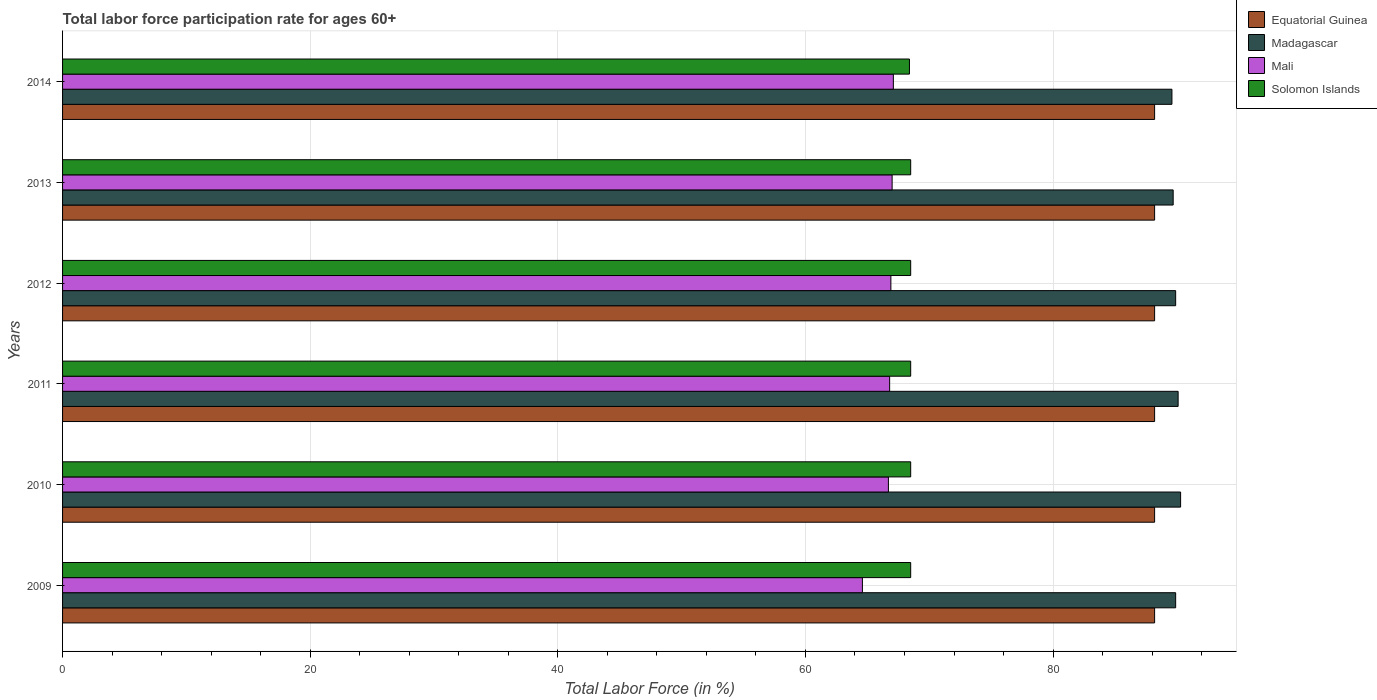How many different coloured bars are there?
Provide a succinct answer. 4. Are the number of bars on each tick of the Y-axis equal?
Offer a terse response. Yes. How many bars are there on the 1st tick from the top?
Offer a very short reply. 4. What is the labor force participation rate in Madagascar in 2014?
Give a very brief answer. 89.6. Across all years, what is the maximum labor force participation rate in Mali?
Keep it short and to the point. 67.1. Across all years, what is the minimum labor force participation rate in Solomon Islands?
Your answer should be very brief. 68.4. In which year was the labor force participation rate in Solomon Islands maximum?
Provide a short and direct response. 2009. What is the total labor force participation rate in Equatorial Guinea in the graph?
Make the answer very short. 529.2. What is the difference between the labor force participation rate in Mali in 2010 and that in 2012?
Your response must be concise. -0.2. What is the difference between the labor force participation rate in Equatorial Guinea in 2009 and the labor force participation rate in Mali in 2013?
Your response must be concise. 21.2. What is the average labor force participation rate in Madagascar per year?
Your response must be concise. 89.92. In the year 2011, what is the difference between the labor force participation rate in Solomon Islands and labor force participation rate in Madagascar?
Give a very brief answer. -21.6. Is the labor force participation rate in Solomon Islands in 2011 less than that in 2012?
Ensure brevity in your answer.  No. Is the difference between the labor force participation rate in Solomon Islands in 2009 and 2010 greater than the difference between the labor force participation rate in Madagascar in 2009 and 2010?
Give a very brief answer. Yes. What is the difference between the highest and the second highest labor force participation rate in Madagascar?
Your answer should be compact. 0.2. What is the difference between the highest and the lowest labor force participation rate in Equatorial Guinea?
Provide a succinct answer. 0. In how many years, is the labor force participation rate in Mali greater than the average labor force participation rate in Mali taken over all years?
Your answer should be compact. 5. Is it the case that in every year, the sum of the labor force participation rate in Equatorial Guinea and labor force participation rate in Mali is greater than the sum of labor force participation rate in Madagascar and labor force participation rate in Solomon Islands?
Your response must be concise. No. What does the 1st bar from the top in 2012 represents?
Your answer should be very brief. Solomon Islands. What does the 4th bar from the bottom in 2010 represents?
Provide a succinct answer. Solomon Islands. Is it the case that in every year, the sum of the labor force participation rate in Madagascar and labor force participation rate in Mali is greater than the labor force participation rate in Solomon Islands?
Give a very brief answer. Yes. How many bars are there?
Provide a short and direct response. 24. Are all the bars in the graph horizontal?
Provide a short and direct response. Yes. How many years are there in the graph?
Keep it short and to the point. 6. What is the difference between two consecutive major ticks on the X-axis?
Provide a succinct answer. 20. Are the values on the major ticks of X-axis written in scientific E-notation?
Provide a short and direct response. No. Does the graph contain any zero values?
Offer a terse response. No. Does the graph contain grids?
Your answer should be compact. Yes. What is the title of the graph?
Keep it short and to the point. Total labor force participation rate for ages 60+. Does "Burundi" appear as one of the legend labels in the graph?
Make the answer very short. No. What is the label or title of the Y-axis?
Your answer should be very brief. Years. What is the Total Labor Force (in %) in Equatorial Guinea in 2009?
Your answer should be compact. 88.2. What is the Total Labor Force (in %) in Madagascar in 2009?
Give a very brief answer. 89.9. What is the Total Labor Force (in %) in Mali in 2009?
Provide a succinct answer. 64.6. What is the Total Labor Force (in %) of Solomon Islands in 2009?
Offer a very short reply. 68.5. What is the Total Labor Force (in %) of Equatorial Guinea in 2010?
Offer a terse response. 88.2. What is the Total Labor Force (in %) of Madagascar in 2010?
Provide a short and direct response. 90.3. What is the Total Labor Force (in %) of Mali in 2010?
Offer a terse response. 66.7. What is the Total Labor Force (in %) in Solomon Islands in 2010?
Your answer should be compact. 68.5. What is the Total Labor Force (in %) in Equatorial Guinea in 2011?
Ensure brevity in your answer.  88.2. What is the Total Labor Force (in %) in Madagascar in 2011?
Give a very brief answer. 90.1. What is the Total Labor Force (in %) of Mali in 2011?
Offer a very short reply. 66.8. What is the Total Labor Force (in %) of Solomon Islands in 2011?
Provide a succinct answer. 68.5. What is the Total Labor Force (in %) of Equatorial Guinea in 2012?
Keep it short and to the point. 88.2. What is the Total Labor Force (in %) in Madagascar in 2012?
Keep it short and to the point. 89.9. What is the Total Labor Force (in %) in Mali in 2012?
Give a very brief answer. 66.9. What is the Total Labor Force (in %) of Solomon Islands in 2012?
Your response must be concise. 68.5. What is the Total Labor Force (in %) in Equatorial Guinea in 2013?
Your answer should be very brief. 88.2. What is the Total Labor Force (in %) in Madagascar in 2013?
Your answer should be very brief. 89.7. What is the Total Labor Force (in %) of Solomon Islands in 2013?
Your response must be concise. 68.5. What is the Total Labor Force (in %) of Equatorial Guinea in 2014?
Provide a succinct answer. 88.2. What is the Total Labor Force (in %) of Madagascar in 2014?
Offer a terse response. 89.6. What is the Total Labor Force (in %) in Mali in 2014?
Provide a succinct answer. 67.1. What is the Total Labor Force (in %) of Solomon Islands in 2014?
Provide a short and direct response. 68.4. Across all years, what is the maximum Total Labor Force (in %) in Equatorial Guinea?
Provide a short and direct response. 88.2. Across all years, what is the maximum Total Labor Force (in %) in Madagascar?
Provide a short and direct response. 90.3. Across all years, what is the maximum Total Labor Force (in %) in Mali?
Your answer should be very brief. 67.1. Across all years, what is the maximum Total Labor Force (in %) in Solomon Islands?
Offer a very short reply. 68.5. Across all years, what is the minimum Total Labor Force (in %) in Equatorial Guinea?
Your answer should be very brief. 88.2. Across all years, what is the minimum Total Labor Force (in %) in Madagascar?
Your answer should be very brief. 89.6. Across all years, what is the minimum Total Labor Force (in %) of Mali?
Offer a terse response. 64.6. Across all years, what is the minimum Total Labor Force (in %) of Solomon Islands?
Your answer should be compact. 68.4. What is the total Total Labor Force (in %) in Equatorial Guinea in the graph?
Make the answer very short. 529.2. What is the total Total Labor Force (in %) of Madagascar in the graph?
Give a very brief answer. 539.5. What is the total Total Labor Force (in %) in Mali in the graph?
Your answer should be compact. 399.1. What is the total Total Labor Force (in %) in Solomon Islands in the graph?
Ensure brevity in your answer.  410.9. What is the difference between the Total Labor Force (in %) of Equatorial Guinea in 2009 and that in 2010?
Ensure brevity in your answer.  0. What is the difference between the Total Labor Force (in %) in Madagascar in 2009 and that in 2010?
Provide a short and direct response. -0.4. What is the difference between the Total Labor Force (in %) of Mali in 2009 and that in 2010?
Your answer should be very brief. -2.1. What is the difference between the Total Labor Force (in %) in Mali in 2009 and that in 2011?
Offer a very short reply. -2.2. What is the difference between the Total Labor Force (in %) in Solomon Islands in 2009 and that in 2011?
Your answer should be compact. 0. What is the difference between the Total Labor Force (in %) in Madagascar in 2009 and that in 2012?
Offer a very short reply. 0. What is the difference between the Total Labor Force (in %) of Mali in 2009 and that in 2012?
Offer a terse response. -2.3. What is the difference between the Total Labor Force (in %) of Solomon Islands in 2009 and that in 2012?
Offer a very short reply. 0. What is the difference between the Total Labor Force (in %) of Madagascar in 2009 and that in 2013?
Provide a short and direct response. 0.2. What is the difference between the Total Labor Force (in %) of Mali in 2009 and that in 2013?
Give a very brief answer. -2.4. What is the difference between the Total Labor Force (in %) in Solomon Islands in 2009 and that in 2013?
Offer a very short reply. 0. What is the difference between the Total Labor Force (in %) of Equatorial Guinea in 2009 and that in 2014?
Your answer should be very brief. 0. What is the difference between the Total Labor Force (in %) of Mali in 2009 and that in 2014?
Your answer should be very brief. -2.5. What is the difference between the Total Labor Force (in %) in Equatorial Guinea in 2010 and that in 2011?
Your response must be concise. 0. What is the difference between the Total Labor Force (in %) of Mali in 2010 and that in 2011?
Keep it short and to the point. -0.1. What is the difference between the Total Labor Force (in %) in Solomon Islands in 2010 and that in 2012?
Offer a terse response. 0. What is the difference between the Total Labor Force (in %) of Mali in 2010 and that in 2013?
Provide a succinct answer. -0.3. What is the difference between the Total Labor Force (in %) in Solomon Islands in 2010 and that in 2013?
Offer a very short reply. 0. What is the difference between the Total Labor Force (in %) in Equatorial Guinea in 2010 and that in 2014?
Offer a terse response. 0. What is the difference between the Total Labor Force (in %) of Mali in 2010 and that in 2014?
Your response must be concise. -0.4. What is the difference between the Total Labor Force (in %) of Mali in 2011 and that in 2012?
Provide a succinct answer. -0.1. What is the difference between the Total Labor Force (in %) of Solomon Islands in 2011 and that in 2012?
Your answer should be compact. 0. What is the difference between the Total Labor Force (in %) in Solomon Islands in 2011 and that in 2013?
Ensure brevity in your answer.  0. What is the difference between the Total Labor Force (in %) in Mali in 2011 and that in 2014?
Ensure brevity in your answer.  -0.3. What is the difference between the Total Labor Force (in %) of Equatorial Guinea in 2012 and that in 2013?
Offer a very short reply. 0. What is the difference between the Total Labor Force (in %) of Mali in 2012 and that in 2013?
Offer a terse response. -0.1. What is the difference between the Total Labor Force (in %) of Solomon Islands in 2012 and that in 2013?
Offer a terse response. 0. What is the difference between the Total Labor Force (in %) in Equatorial Guinea in 2012 and that in 2014?
Your answer should be very brief. 0. What is the difference between the Total Labor Force (in %) in Madagascar in 2012 and that in 2014?
Offer a very short reply. 0.3. What is the difference between the Total Labor Force (in %) of Madagascar in 2013 and that in 2014?
Offer a terse response. 0.1. What is the difference between the Total Labor Force (in %) in Equatorial Guinea in 2009 and the Total Labor Force (in %) in Mali in 2010?
Give a very brief answer. 21.5. What is the difference between the Total Labor Force (in %) of Madagascar in 2009 and the Total Labor Force (in %) of Mali in 2010?
Offer a very short reply. 23.2. What is the difference between the Total Labor Force (in %) in Madagascar in 2009 and the Total Labor Force (in %) in Solomon Islands in 2010?
Provide a short and direct response. 21.4. What is the difference between the Total Labor Force (in %) of Mali in 2009 and the Total Labor Force (in %) of Solomon Islands in 2010?
Provide a short and direct response. -3.9. What is the difference between the Total Labor Force (in %) of Equatorial Guinea in 2009 and the Total Labor Force (in %) of Madagascar in 2011?
Your response must be concise. -1.9. What is the difference between the Total Labor Force (in %) of Equatorial Guinea in 2009 and the Total Labor Force (in %) of Mali in 2011?
Give a very brief answer. 21.4. What is the difference between the Total Labor Force (in %) of Equatorial Guinea in 2009 and the Total Labor Force (in %) of Solomon Islands in 2011?
Ensure brevity in your answer.  19.7. What is the difference between the Total Labor Force (in %) in Madagascar in 2009 and the Total Labor Force (in %) in Mali in 2011?
Your answer should be compact. 23.1. What is the difference between the Total Labor Force (in %) in Madagascar in 2009 and the Total Labor Force (in %) in Solomon Islands in 2011?
Offer a terse response. 21.4. What is the difference between the Total Labor Force (in %) in Equatorial Guinea in 2009 and the Total Labor Force (in %) in Mali in 2012?
Your answer should be very brief. 21.3. What is the difference between the Total Labor Force (in %) of Equatorial Guinea in 2009 and the Total Labor Force (in %) of Solomon Islands in 2012?
Your answer should be compact. 19.7. What is the difference between the Total Labor Force (in %) in Madagascar in 2009 and the Total Labor Force (in %) in Solomon Islands in 2012?
Ensure brevity in your answer.  21.4. What is the difference between the Total Labor Force (in %) of Mali in 2009 and the Total Labor Force (in %) of Solomon Islands in 2012?
Keep it short and to the point. -3.9. What is the difference between the Total Labor Force (in %) in Equatorial Guinea in 2009 and the Total Labor Force (in %) in Mali in 2013?
Provide a succinct answer. 21.2. What is the difference between the Total Labor Force (in %) in Equatorial Guinea in 2009 and the Total Labor Force (in %) in Solomon Islands in 2013?
Ensure brevity in your answer.  19.7. What is the difference between the Total Labor Force (in %) of Madagascar in 2009 and the Total Labor Force (in %) of Mali in 2013?
Your answer should be very brief. 22.9. What is the difference between the Total Labor Force (in %) in Madagascar in 2009 and the Total Labor Force (in %) in Solomon Islands in 2013?
Provide a succinct answer. 21.4. What is the difference between the Total Labor Force (in %) of Mali in 2009 and the Total Labor Force (in %) of Solomon Islands in 2013?
Your answer should be very brief. -3.9. What is the difference between the Total Labor Force (in %) of Equatorial Guinea in 2009 and the Total Labor Force (in %) of Mali in 2014?
Offer a very short reply. 21.1. What is the difference between the Total Labor Force (in %) in Equatorial Guinea in 2009 and the Total Labor Force (in %) in Solomon Islands in 2014?
Your answer should be very brief. 19.8. What is the difference between the Total Labor Force (in %) of Madagascar in 2009 and the Total Labor Force (in %) of Mali in 2014?
Give a very brief answer. 22.8. What is the difference between the Total Labor Force (in %) in Madagascar in 2009 and the Total Labor Force (in %) in Solomon Islands in 2014?
Your response must be concise. 21.5. What is the difference between the Total Labor Force (in %) in Equatorial Guinea in 2010 and the Total Labor Force (in %) in Madagascar in 2011?
Provide a short and direct response. -1.9. What is the difference between the Total Labor Force (in %) in Equatorial Guinea in 2010 and the Total Labor Force (in %) in Mali in 2011?
Keep it short and to the point. 21.4. What is the difference between the Total Labor Force (in %) in Madagascar in 2010 and the Total Labor Force (in %) in Solomon Islands in 2011?
Ensure brevity in your answer.  21.8. What is the difference between the Total Labor Force (in %) of Equatorial Guinea in 2010 and the Total Labor Force (in %) of Mali in 2012?
Give a very brief answer. 21.3. What is the difference between the Total Labor Force (in %) in Equatorial Guinea in 2010 and the Total Labor Force (in %) in Solomon Islands in 2012?
Your answer should be compact. 19.7. What is the difference between the Total Labor Force (in %) of Madagascar in 2010 and the Total Labor Force (in %) of Mali in 2012?
Give a very brief answer. 23.4. What is the difference between the Total Labor Force (in %) of Madagascar in 2010 and the Total Labor Force (in %) of Solomon Islands in 2012?
Provide a succinct answer. 21.8. What is the difference between the Total Labor Force (in %) in Mali in 2010 and the Total Labor Force (in %) in Solomon Islands in 2012?
Offer a terse response. -1.8. What is the difference between the Total Labor Force (in %) in Equatorial Guinea in 2010 and the Total Labor Force (in %) in Madagascar in 2013?
Your answer should be very brief. -1.5. What is the difference between the Total Labor Force (in %) of Equatorial Guinea in 2010 and the Total Labor Force (in %) of Mali in 2013?
Keep it short and to the point. 21.2. What is the difference between the Total Labor Force (in %) in Equatorial Guinea in 2010 and the Total Labor Force (in %) in Solomon Islands in 2013?
Your answer should be compact. 19.7. What is the difference between the Total Labor Force (in %) of Madagascar in 2010 and the Total Labor Force (in %) of Mali in 2013?
Offer a very short reply. 23.3. What is the difference between the Total Labor Force (in %) in Madagascar in 2010 and the Total Labor Force (in %) in Solomon Islands in 2013?
Your answer should be very brief. 21.8. What is the difference between the Total Labor Force (in %) of Equatorial Guinea in 2010 and the Total Labor Force (in %) of Madagascar in 2014?
Give a very brief answer. -1.4. What is the difference between the Total Labor Force (in %) in Equatorial Guinea in 2010 and the Total Labor Force (in %) in Mali in 2014?
Offer a terse response. 21.1. What is the difference between the Total Labor Force (in %) in Equatorial Guinea in 2010 and the Total Labor Force (in %) in Solomon Islands in 2014?
Offer a very short reply. 19.8. What is the difference between the Total Labor Force (in %) of Madagascar in 2010 and the Total Labor Force (in %) of Mali in 2014?
Offer a terse response. 23.2. What is the difference between the Total Labor Force (in %) in Madagascar in 2010 and the Total Labor Force (in %) in Solomon Islands in 2014?
Keep it short and to the point. 21.9. What is the difference between the Total Labor Force (in %) in Equatorial Guinea in 2011 and the Total Labor Force (in %) in Mali in 2012?
Ensure brevity in your answer.  21.3. What is the difference between the Total Labor Force (in %) of Equatorial Guinea in 2011 and the Total Labor Force (in %) of Solomon Islands in 2012?
Your response must be concise. 19.7. What is the difference between the Total Labor Force (in %) of Madagascar in 2011 and the Total Labor Force (in %) of Mali in 2012?
Your answer should be very brief. 23.2. What is the difference between the Total Labor Force (in %) in Madagascar in 2011 and the Total Labor Force (in %) in Solomon Islands in 2012?
Your answer should be very brief. 21.6. What is the difference between the Total Labor Force (in %) in Mali in 2011 and the Total Labor Force (in %) in Solomon Islands in 2012?
Provide a short and direct response. -1.7. What is the difference between the Total Labor Force (in %) in Equatorial Guinea in 2011 and the Total Labor Force (in %) in Mali in 2013?
Give a very brief answer. 21.2. What is the difference between the Total Labor Force (in %) in Equatorial Guinea in 2011 and the Total Labor Force (in %) in Solomon Islands in 2013?
Keep it short and to the point. 19.7. What is the difference between the Total Labor Force (in %) of Madagascar in 2011 and the Total Labor Force (in %) of Mali in 2013?
Offer a terse response. 23.1. What is the difference between the Total Labor Force (in %) in Madagascar in 2011 and the Total Labor Force (in %) in Solomon Islands in 2013?
Offer a very short reply. 21.6. What is the difference between the Total Labor Force (in %) in Mali in 2011 and the Total Labor Force (in %) in Solomon Islands in 2013?
Your answer should be compact. -1.7. What is the difference between the Total Labor Force (in %) in Equatorial Guinea in 2011 and the Total Labor Force (in %) in Mali in 2014?
Provide a short and direct response. 21.1. What is the difference between the Total Labor Force (in %) of Equatorial Guinea in 2011 and the Total Labor Force (in %) of Solomon Islands in 2014?
Your response must be concise. 19.8. What is the difference between the Total Labor Force (in %) of Madagascar in 2011 and the Total Labor Force (in %) of Solomon Islands in 2014?
Your answer should be very brief. 21.7. What is the difference between the Total Labor Force (in %) in Equatorial Guinea in 2012 and the Total Labor Force (in %) in Mali in 2013?
Offer a terse response. 21.2. What is the difference between the Total Labor Force (in %) of Equatorial Guinea in 2012 and the Total Labor Force (in %) of Solomon Islands in 2013?
Give a very brief answer. 19.7. What is the difference between the Total Labor Force (in %) of Madagascar in 2012 and the Total Labor Force (in %) of Mali in 2013?
Offer a very short reply. 22.9. What is the difference between the Total Labor Force (in %) in Madagascar in 2012 and the Total Labor Force (in %) in Solomon Islands in 2013?
Your answer should be very brief. 21.4. What is the difference between the Total Labor Force (in %) of Mali in 2012 and the Total Labor Force (in %) of Solomon Islands in 2013?
Offer a terse response. -1.6. What is the difference between the Total Labor Force (in %) in Equatorial Guinea in 2012 and the Total Labor Force (in %) in Mali in 2014?
Keep it short and to the point. 21.1. What is the difference between the Total Labor Force (in %) of Equatorial Guinea in 2012 and the Total Labor Force (in %) of Solomon Islands in 2014?
Provide a succinct answer. 19.8. What is the difference between the Total Labor Force (in %) in Madagascar in 2012 and the Total Labor Force (in %) in Mali in 2014?
Your answer should be very brief. 22.8. What is the difference between the Total Labor Force (in %) in Madagascar in 2012 and the Total Labor Force (in %) in Solomon Islands in 2014?
Your answer should be compact. 21.5. What is the difference between the Total Labor Force (in %) of Mali in 2012 and the Total Labor Force (in %) of Solomon Islands in 2014?
Your answer should be very brief. -1.5. What is the difference between the Total Labor Force (in %) in Equatorial Guinea in 2013 and the Total Labor Force (in %) in Mali in 2014?
Provide a short and direct response. 21.1. What is the difference between the Total Labor Force (in %) of Equatorial Guinea in 2013 and the Total Labor Force (in %) of Solomon Islands in 2014?
Provide a short and direct response. 19.8. What is the difference between the Total Labor Force (in %) of Madagascar in 2013 and the Total Labor Force (in %) of Mali in 2014?
Provide a short and direct response. 22.6. What is the difference between the Total Labor Force (in %) of Madagascar in 2013 and the Total Labor Force (in %) of Solomon Islands in 2014?
Your answer should be very brief. 21.3. What is the difference between the Total Labor Force (in %) in Mali in 2013 and the Total Labor Force (in %) in Solomon Islands in 2014?
Ensure brevity in your answer.  -1.4. What is the average Total Labor Force (in %) of Equatorial Guinea per year?
Your answer should be very brief. 88.2. What is the average Total Labor Force (in %) of Madagascar per year?
Your answer should be compact. 89.92. What is the average Total Labor Force (in %) in Mali per year?
Provide a short and direct response. 66.52. What is the average Total Labor Force (in %) in Solomon Islands per year?
Your answer should be very brief. 68.48. In the year 2009, what is the difference between the Total Labor Force (in %) in Equatorial Guinea and Total Labor Force (in %) in Madagascar?
Make the answer very short. -1.7. In the year 2009, what is the difference between the Total Labor Force (in %) in Equatorial Guinea and Total Labor Force (in %) in Mali?
Keep it short and to the point. 23.6. In the year 2009, what is the difference between the Total Labor Force (in %) in Madagascar and Total Labor Force (in %) in Mali?
Offer a terse response. 25.3. In the year 2009, what is the difference between the Total Labor Force (in %) in Madagascar and Total Labor Force (in %) in Solomon Islands?
Make the answer very short. 21.4. In the year 2010, what is the difference between the Total Labor Force (in %) in Equatorial Guinea and Total Labor Force (in %) in Mali?
Offer a terse response. 21.5. In the year 2010, what is the difference between the Total Labor Force (in %) of Equatorial Guinea and Total Labor Force (in %) of Solomon Islands?
Provide a succinct answer. 19.7. In the year 2010, what is the difference between the Total Labor Force (in %) of Madagascar and Total Labor Force (in %) of Mali?
Offer a very short reply. 23.6. In the year 2010, what is the difference between the Total Labor Force (in %) of Madagascar and Total Labor Force (in %) of Solomon Islands?
Give a very brief answer. 21.8. In the year 2010, what is the difference between the Total Labor Force (in %) in Mali and Total Labor Force (in %) in Solomon Islands?
Ensure brevity in your answer.  -1.8. In the year 2011, what is the difference between the Total Labor Force (in %) of Equatorial Guinea and Total Labor Force (in %) of Madagascar?
Offer a very short reply. -1.9. In the year 2011, what is the difference between the Total Labor Force (in %) of Equatorial Guinea and Total Labor Force (in %) of Mali?
Give a very brief answer. 21.4. In the year 2011, what is the difference between the Total Labor Force (in %) in Equatorial Guinea and Total Labor Force (in %) in Solomon Islands?
Provide a succinct answer. 19.7. In the year 2011, what is the difference between the Total Labor Force (in %) of Madagascar and Total Labor Force (in %) of Mali?
Your answer should be very brief. 23.3. In the year 2011, what is the difference between the Total Labor Force (in %) of Madagascar and Total Labor Force (in %) of Solomon Islands?
Give a very brief answer. 21.6. In the year 2011, what is the difference between the Total Labor Force (in %) of Mali and Total Labor Force (in %) of Solomon Islands?
Your response must be concise. -1.7. In the year 2012, what is the difference between the Total Labor Force (in %) in Equatorial Guinea and Total Labor Force (in %) in Mali?
Ensure brevity in your answer.  21.3. In the year 2012, what is the difference between the Total Labor Force (in %) in Equatorial Guinea and Total Labor Force (in %) in Solomon Islands?
Ensure brevity in your answer.  19.7. In the year 2012, what is the difference between the Total Labor Force (in %) of Madagascar and Total Labor Force (in %) of Mali?
Your answer should be compact. 23. In the year 2012, what is the difference between the Total Labor Force (in %) in Madagascar and Total Labor Force (in %) in Solomon Islands?
Your answer should be very brief. 21.4. In the year 2013, what is the difference between the Total Labor Force (in %) of Equatorial Guinea and Total Labor Force (in %) of Madagascar?
Your answer should be compact. -1.5. In the year 2013, what is the difference between the Total Labor Force (in %) of Equatorial Guinea and Total Labor Force (in %) of Mali?
Ensure brevity in your answer.  21.2. In the year 2013, what is the difference between the Total Labor Force (in %) of Madagascar and Total Labor Force (in %) of Mali?
Your answer should be very brief. 22.7. In the year 2013, what is the difference between the Total Labor Force (in %) in Madagascar and Total Labor Force (in %) in Solomon Islands?
Ensure brevity in your answer.  21.2. In the year 2013, what is the difference between the Total Labor Force (in %) in Mali and Total Labor Force (in %) in Solomon Islands?
Offer a terse response. -1.5. In the year 2014, what is the difference between the Total Labor Force (in %) in Equatorial Guinea and Total Labor Force (in %) in Madagascar?
Provide a short and direct response. -1.4. In the year 2014, what is the difference between the Total Labor Force (in %) in Equatorial Guinea and Total Labor Force (in %) in Mali?
Make the answer very short. 21.1. In the year 2014, what is the difference between the Total Labor Force (in %) in Equatorial Guinea and Total Labor Force (in %) in Solomon Islands?
Your answer should be compact. 19.8. In the year 2014, what is the difference between the Total Labor Force (in %) of Madagascar and Total Labor Force (in %) of Solomon Islands?
Give a very brief answer. 21.2. What is the ratio of the Total Labor Force (in %) of Madagascar in 2009 to that in 2010?
Your response must be concise. 1. What is the ratio of the Total Labor Force (in %) in Mali in 2009 to that in 2010?
Give a very brief answer. 0.97. What is the ratio of the Total Labor Force (in %) of Madagascar in 2009 to that in 2011?
Provide a succinct answer. 1. What is the ratio of the Total Labor Force (in %) in Mali in 2009 to that in 2011?
Provide a short and direct response. 0.97. What is the ratio of the Total Labor Force (in %) of Mali in 2009 to that in 2012?
Provide a short and direct response. 0.97. What is the ratio of the Total Labor Force (in %) of Equatorial Guinea in 2009 to that in 2013?
Ensure brevity in your answer.  1. What is the ratio of the Total Labor Force (in %) in Madagascar in 2009 to that in 2013?
Your response must be concise. 1. What is the ratio of the Total Labor Force (in %) in Mali in 2009 to that in 2013?
Make the answer very short. 0.96. What is the ratio of the Total Labor Force (in %) in Solomon Islands in 2009 to that in 2013?
Provide a succinct answer. 1. What is the ratio of the Total Labor Force (in %) of Madagascar in 2009 to that in 2014?
Provide a succinct answer. 1. What is the ratio of the Total Labor Force (in %) of Mali in 2009 to that in 2014?
Offer a very short reply. 0.96. What is the ratio of the Total Labor Force (in %) of Solomon Islands in 2009 to that in 2014?
Give a very brief answer. 1. What is the ratio of the Total Labor Force (in %) in Madagascar in 2010 to that in 2011?
Provide a succinct answer. 1. What is the ratio of the Total Labor Force (in %) in Equatorial Guinea in 2010 to that in 2012?
Keep it short and to the point. 1. What is the ratio of the Total Labor Force (in %) in Mali in 2010 to that in 2012?
Offer a terse response. 1. What is the ratio of the Total Labor Force (in %) in Solomon Islands in 2010 to that in 2012?
Make the answer very short. 1. What is the ratio of the Total Labor Force (in %) in Equatorial Guinea in 2010 to that in 2013?
Offer a terse response. 1. What is the ratio of the Total Labor Force (in %) in Solomon Islands in 2010 to that in 2014?
Make the answer very short. 1. What is the ratio of the Total Labor Force (in %) in Equatorial Guinea in 2011 to that in 2012?
Offer a terse response. 1. What is the ratio of the Total Labor Force (in %) in Madagascar in 2011 to that in 2012?
Offer a terse response. 1. What is the ratio of the Total Labor Force (in %) in Solomon Islands in 2011 to that in 2012?
Offer a terse response. 1. What is the ratio of the Total Labor Force (in %) of Madagascar in 2011 to that in 2013?
Your response must be concise. 1. What is the ratio of the Total Labor Force (in %) of Mali in 2011 to that in 2013?
Offer a terse response. 1. What is the ratio of the Total Labor Force (in %) of Madagascar in 2011 to that in 2014?
Your response must be concise. 1.01. What is the ratio of the Total Labor Force (in %) in Solomon Islands in 2011 to that in 2014?
Provide a succinct answer. 1. What is the ratio of the Total Labor Force (in %) of Madagascar in 2012 to that in 2013?
Provide a short and direct response. 1. What is the ratio of the Total Labor Force (in %) in Mali in 2012 to that in 2013?
Give a very brief answer. 1. What is the ratio of the Total Labor Force (in %) in Solomon Islands in 2012 to that in 2013?
Offer a very short reply. 1. What is the ratio of the Total Labor Force (in %) of Madagascar in 2012 to that in 2014?
Offer a very short reply. 1. What is the ratio of the Total Labor Force (in %) of Equatorial Guinea in 2013 to that in 2014?
Keep it short and to the point. 1. What is the ratio of the Total Labor Force (in %) of Madagascar in 2013 to that in 2014?
Your answer should be compact. 1. What is the ratio of the Total Labor Force (in %) of Mali in 2013 to that in 2014?
Keep it short and to the point. 1. What is the ratio of the Total Labor Force (in %) of Solomon Islands in 2013 to that in 2014?
Your answer should be compact. 1. What is the difference between the highest and the second highest Total Labor Force (in %) in Solomon Islands?
Make the answer very short. 0. What is the difference between the highest and the lowest Total Labor Force (in %) in Equatorial Guinea?
Provide a succinct answer. 0. What is the difference between the highest and the lowest Total Labor Force (in %) in Madagascar?
Offer a very short reply. 0.7. What is the difference between the highest and the lowest Total Labor Force (in %) in Solomon Islands?
Keep it short and to the point. 0.1. 